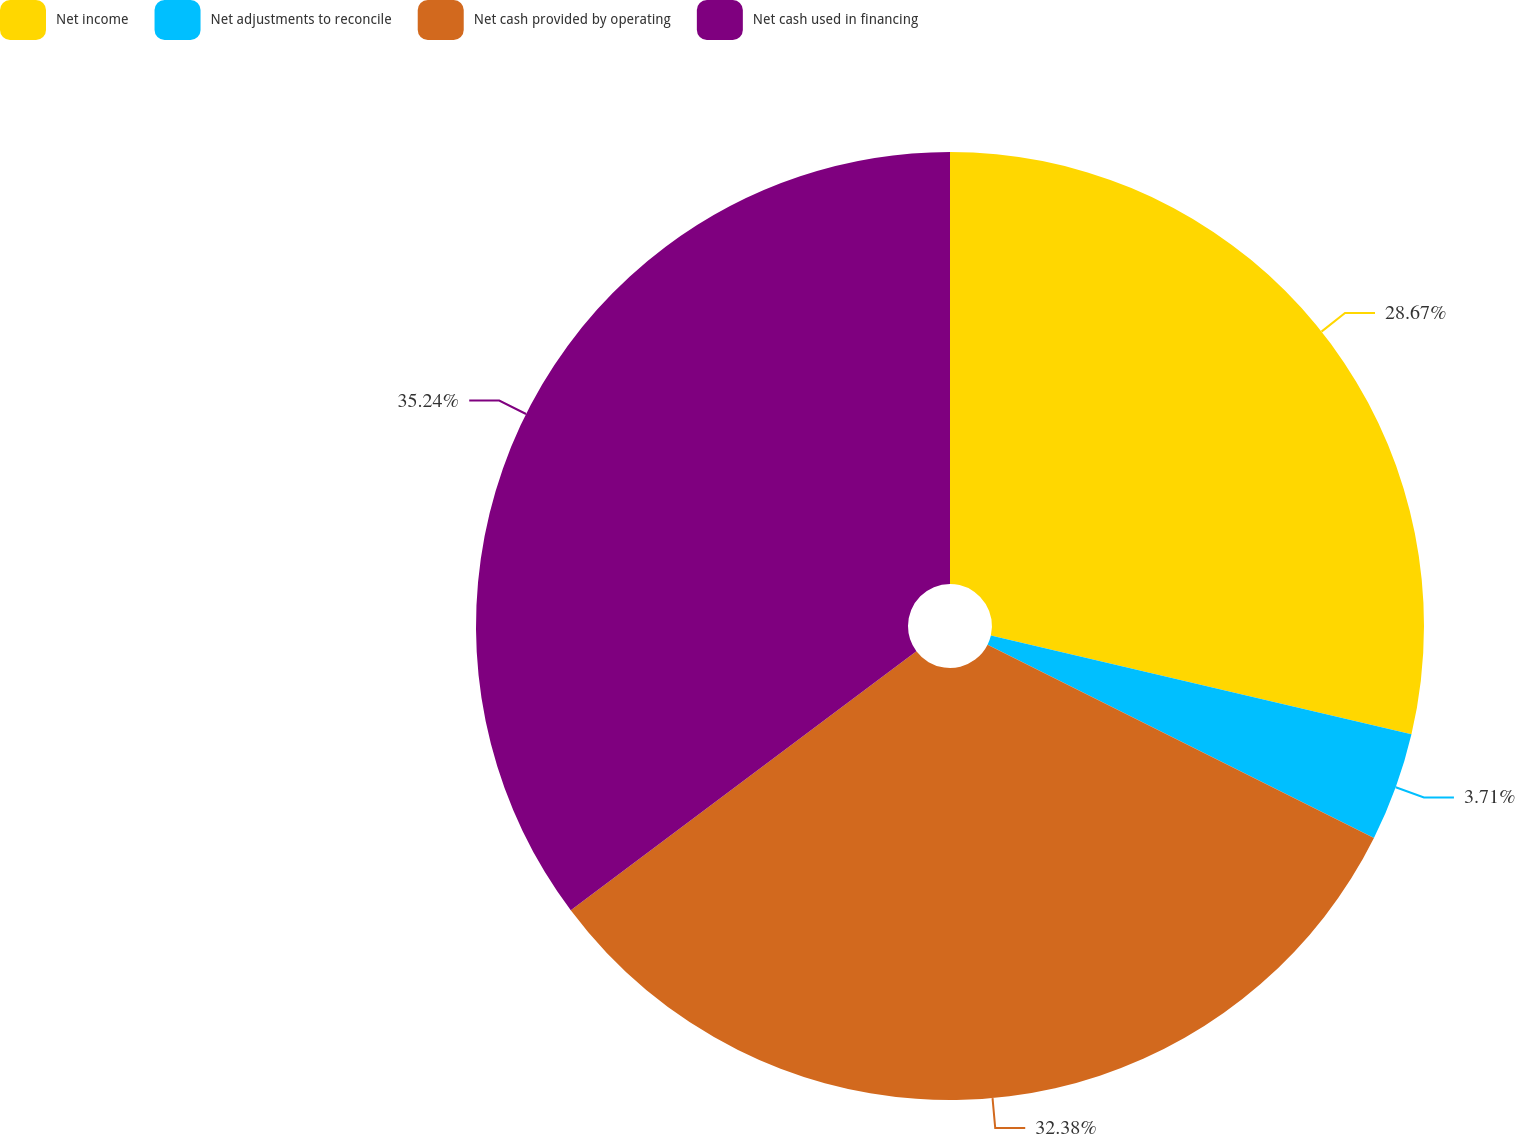<chart> <loc_0><loc_0><loc_500><loc_500><pie_chart><fcel>Net income<fcel>Net adjustments to reconcile<fcel>Net cash provided by operating<fcel>Net cash used in financing<nl><fcel>28.67%<fcel>3.71%<fcel>32.38%<fcel>35.24%<nl></chart> 